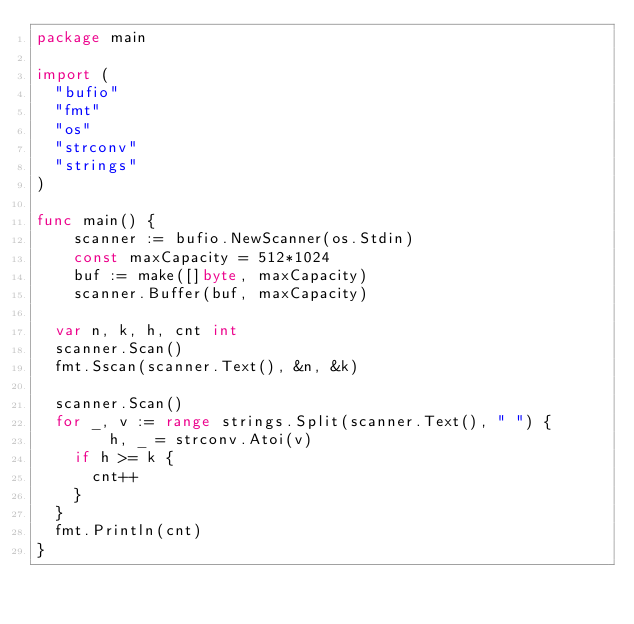<code> <loc_0><loc_0><loc_500><loc_500><_Go_>package main

import (
	"bufio"
	"fmt"
	"os"
	"strconv"
	"strings"
)

func main() {
    scanner := bufio.NewScanner(os.Stdin)
    const maxCapacity = 512*1024  
    buf := make([]byte, maxCapacity)
    scanner.Buffer(buf, maxCapacity)
  
	var n, k, h, cnt int
	scanner.Scan()
	fmt.Sscan(scanner.Text(), &n, &k)

	scanner.Scan()
	for _, v := range strings.Split(scanner.Text(), " ") {
        h, _ = strconv.Atoi(v)
		if h >= k {
			cnt++
		}
	}
	fmt.Println(cnt)
}
</code> 